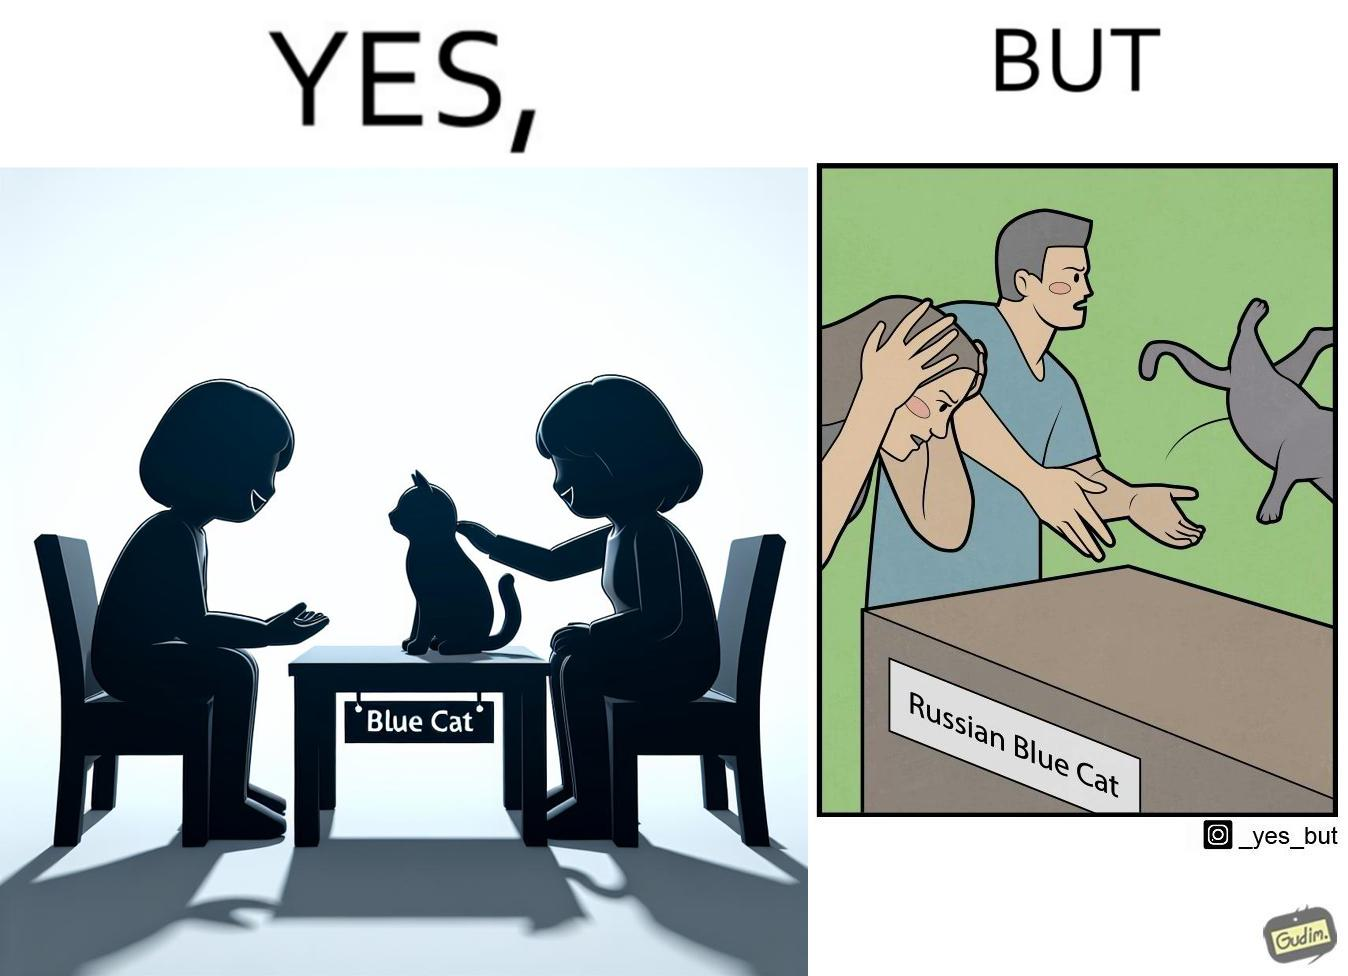What is the satirical meaning behind this image? The image is confusing, as initially, when the label reads "Blue Cat", the people are happy and are petting tha cat, but as soon as one of them realizes that the entire text reads "Russian Blue Cat", they seem to worried, and one of them throws away the cat. For some reason, the word "Russian" is a trigger word for them. 